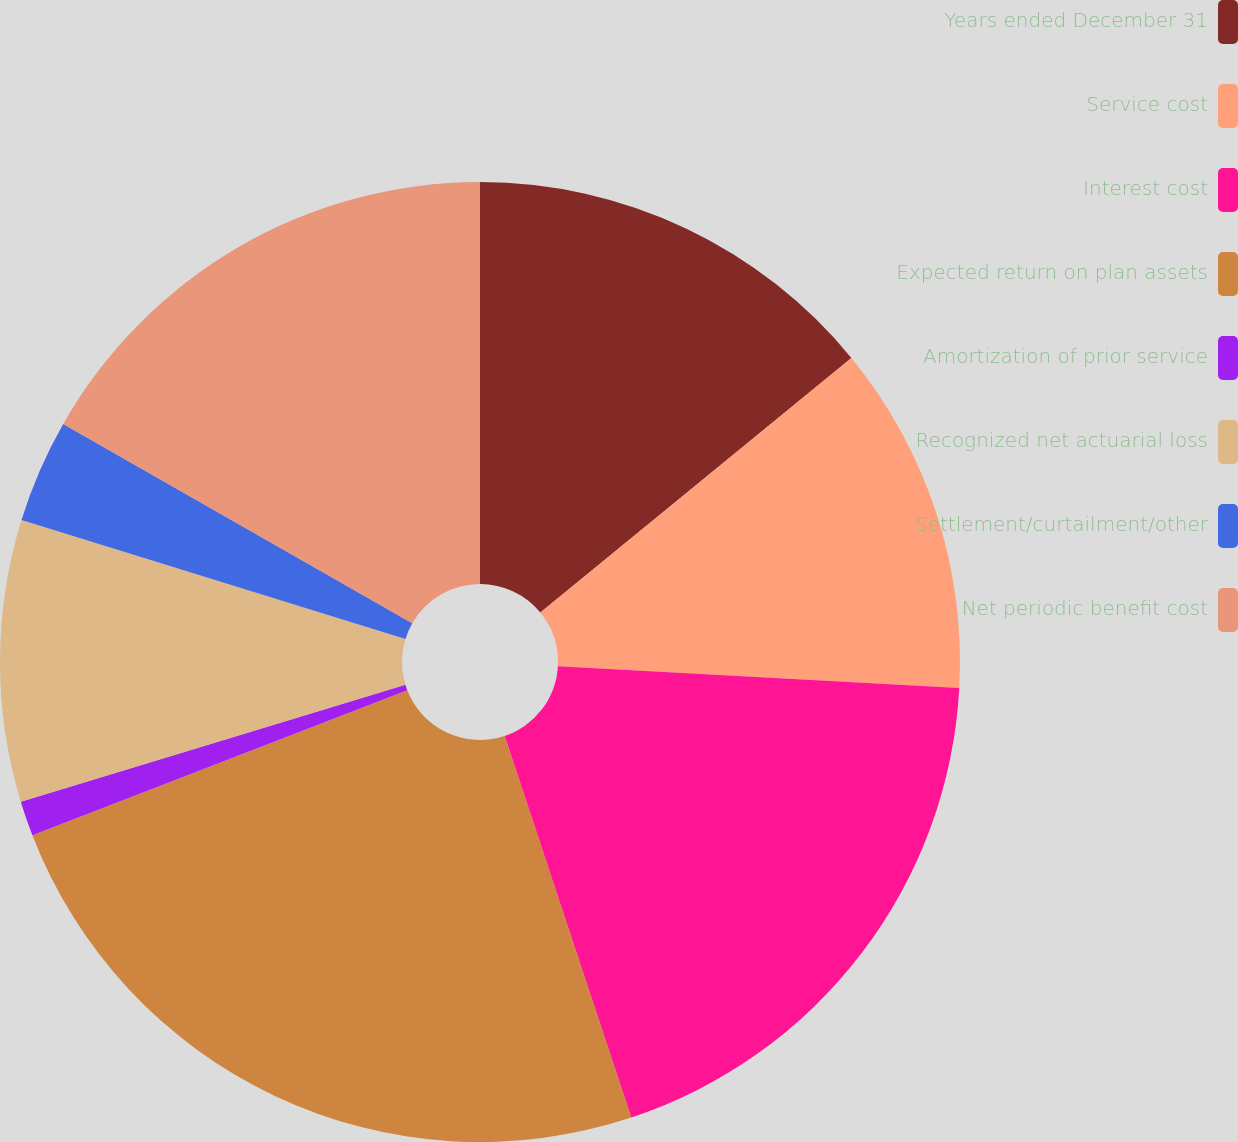Convert chart to OTSL. <chart><loc_0><loc_0><loc_500><loc_500><pie_chart><fcel>Years ended December 31<fcel>Service cost<fcel>Interest cost<fcel>Expected return on plan assets<fcel>Amortization of prior service<fcel>Recognized net actuarial loss<fcel>Settlement/curtailment/other<fcel>Net periodic benefit cost<nl><fcel>14.08%<fcel>11.78%<fcel>19.04%<fcel>24.22%<fcel>1.18%<fcel>9.48%<fcel>3.48%<fcel>16.74%<nl></chart> 